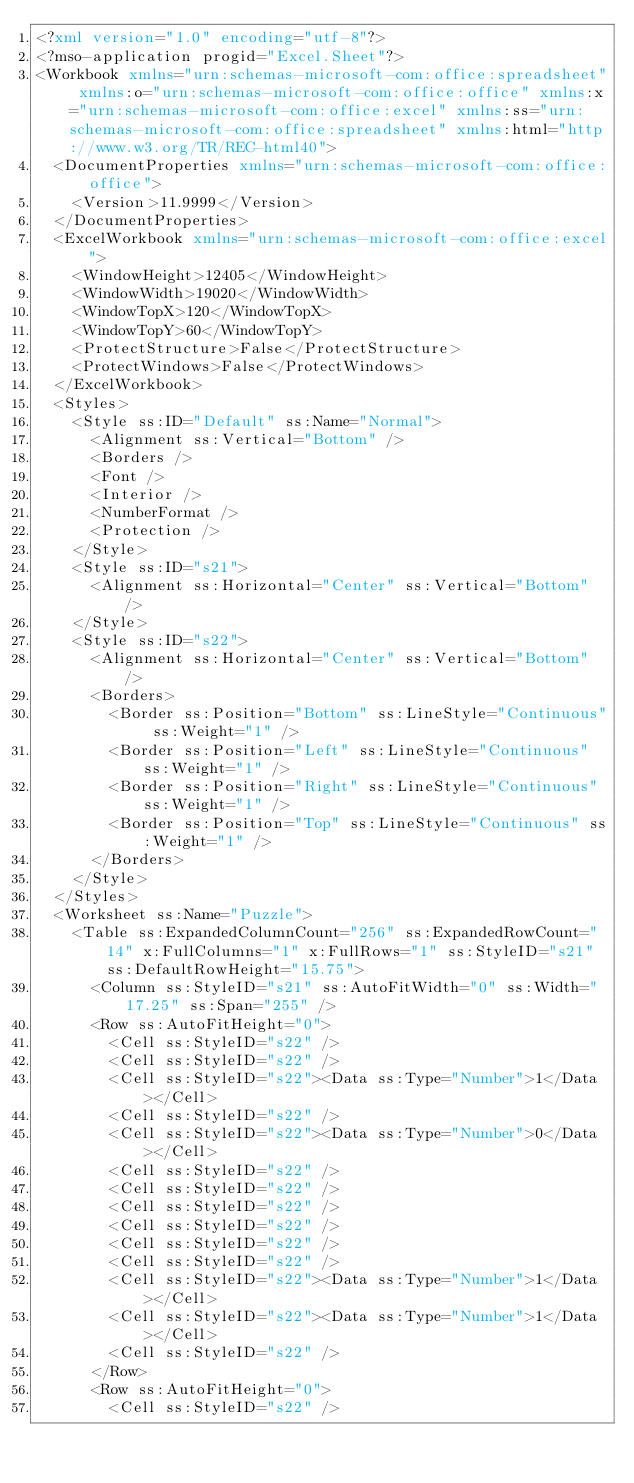<code> <loc_0><loc_0><loc_500><loc_500><_XML_><?xml version="1.0" encoding="utf-8"?>
<?mso-application progid="Excel.Sheet"?>
<Workbook xmlns="urn:schemas-microsoft-com:office:spreadsheet" xmlns:o="urn:schemas-microsoft-com:office:office" xmlns:x="urn:schemas-microsoft-com:office:excel" xmlns:ss="urn:schemas-microsoft-com:office:spreadsheet" xmlns:html="http://www.w3.org/TR/REC-html40">
  <DocumentProperties xmlns="urn:schemas-microsoft-com:office:office">
    <Version>11.9999</Version>
  </DocumentProperties>
  <ExcelWorkbook xmlns="urn:schemas-microsoft-com:office:excel">
    <WindowHeight>12405</WindowHeight>
    <WindowWidth>19020</WindowWidth>
    <WindowTopX>120</WindowTopX>
    <WindowTopY>60</WindowTopY>
    <ProtectStructure>False</ProtectStructure>
    <ProtectWindows>False</ProtectWindows>
  </ExcelWorkbook>
  <Styles>
    <Style ss:ID="Default" ss:Name="Normal">
      <Alignment ss:Vertical="Bottom" />
      <Borders />
      <Font />
      <Interior />
      <NumberFormat />
      <Protection />
    </Style>
    <Style ss:ID="s21">
      <Alignment ss:Horizontal="Center" ss:Vertical="Bottom" />
    </Style>
    <Style ss:ID="s22">
      <Alignment ss:Horizontal="Center" ss:Vertical="Bottom" />
      <Borders>
        <Border ss:Position="Bottom" ss:LineStyle="Continuous" ss:Weight="1" />
        <Border ss:Position="Left" ss:LineStyle="Continuous" ss:Weight="1" />
        <Border ss:Position="Right" ss:LineStyle="Continuous" ss:Weight="1" />
        <Border ss:Position="Top" ss:LineStyle="Continuous" ss:Weight="1" />
      </Borders>
    </Style>
  </Styles>
  <Worksheet ss:Name="Puzzle">
    <Table ss:ExpandedColumnCount="256" ss:ExpandedRowCount="14" x:FullColumns="1" x:FullRows="1" ss:StyleID="s21" ss:DefaultRowHeight="15.75">
      <Column ss:StyleID="s21" ss:AutoFitWidth="0" ss:Width="17.25" ss:Span="255" />
      <Row ss:AutoFitHeight="0">
        <Cell ss:StyleID="s22" />
        <Cell ss:StyleID="s22" />
        <Cell ss:StyleID="s22"><Data ss:Type="Number">1</Data></Cell>
        <Cell ss:StyleID="s22" />
        <Cell ss:StyleID="s22"><Data ss:Type="Number">0</Data></Cell>
        <Cell ss:StyleID="s22" />
        <Cell ss:StyleID="s22" />
        <Cell ss:StyleID="s22" />
        <Cell ss:StyleID="s22" />
        <Cell ss:StyleID="s22" />
        <Cell ss:StyleID="s22" />
        <Cell ss:StyleID="s22"><Data ss:Type="Number">1</Data></Cell>
        <Cell ss:StyleID="s22"><Data ss:Type="Number">1</Data></Cell>
        <Cell ss:StyleID="s22" />
      </Row>
      <Row ss:AutoFitHeight="0">
        <Cell ss:StyleID="s22" /></code> 